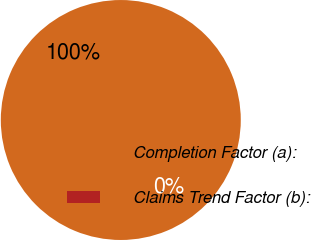Convert chart. <chart><loc_0><loc_0><loc_500><loc_500><pie_chart><fcel>Completion Factor (a):<fcel>Claims Trend Factor (b):<nl><fcel>100.0%<fcel>0.0%<nl></chart> 